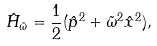<formula> <loc_0><loc_0><loc_500><loc_500>\hat { H } _ { \tilde { \omega } } = \frac { 1 } { 2 } ( \hat { p } ^ { 2 } + \tilde { \omega } ^ { 2 } \hat { x } ^ { 2 } ) ,</formula> 